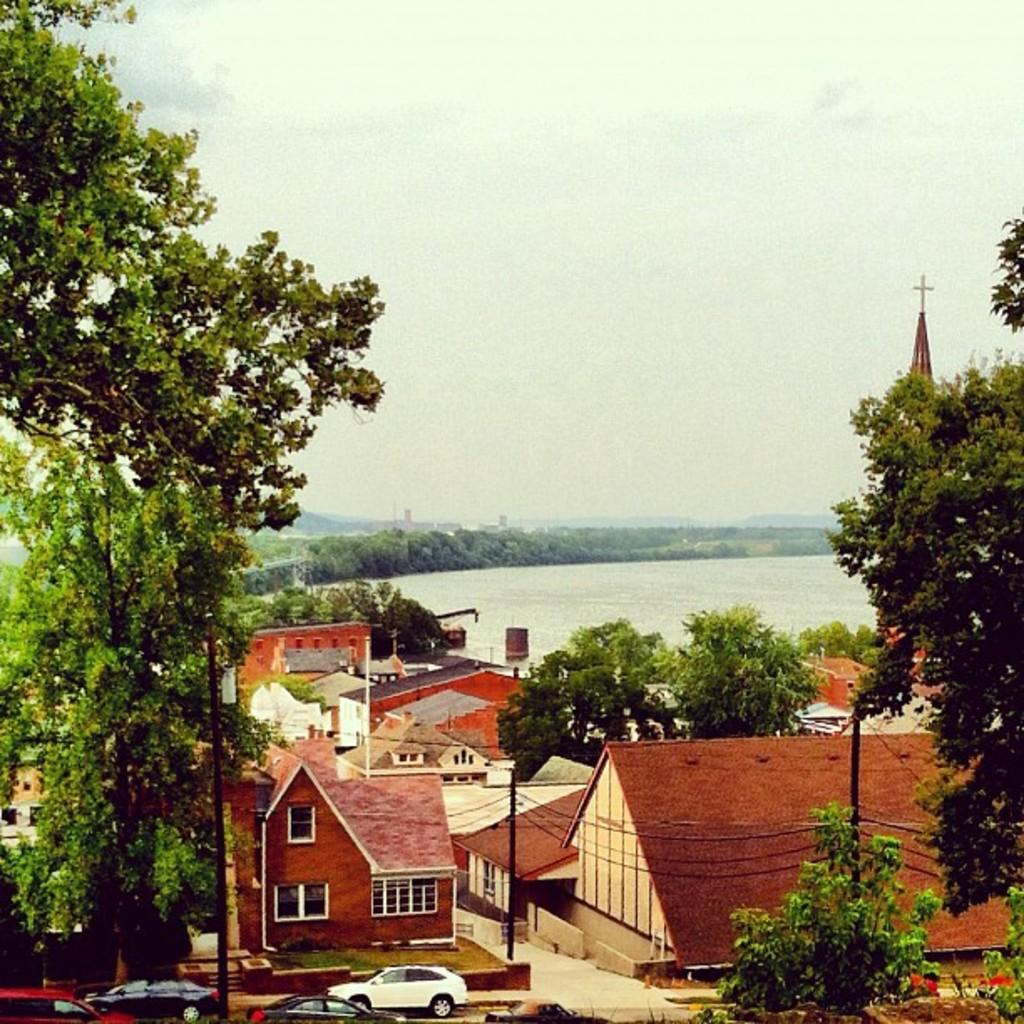What type of structures can be seen in the image? There are many houses in the image. What other natural elements are present in the image? There are trees in the image. What are the cars doing in front of the houses? The cars are parked in front of the houses. What can be seen behind the trees in the image? There is a water surface behind the trees. What letter is written on the bottle in the image? There is no bottle present in the image. What month is it in the image? The image does not provide any information about the month. 